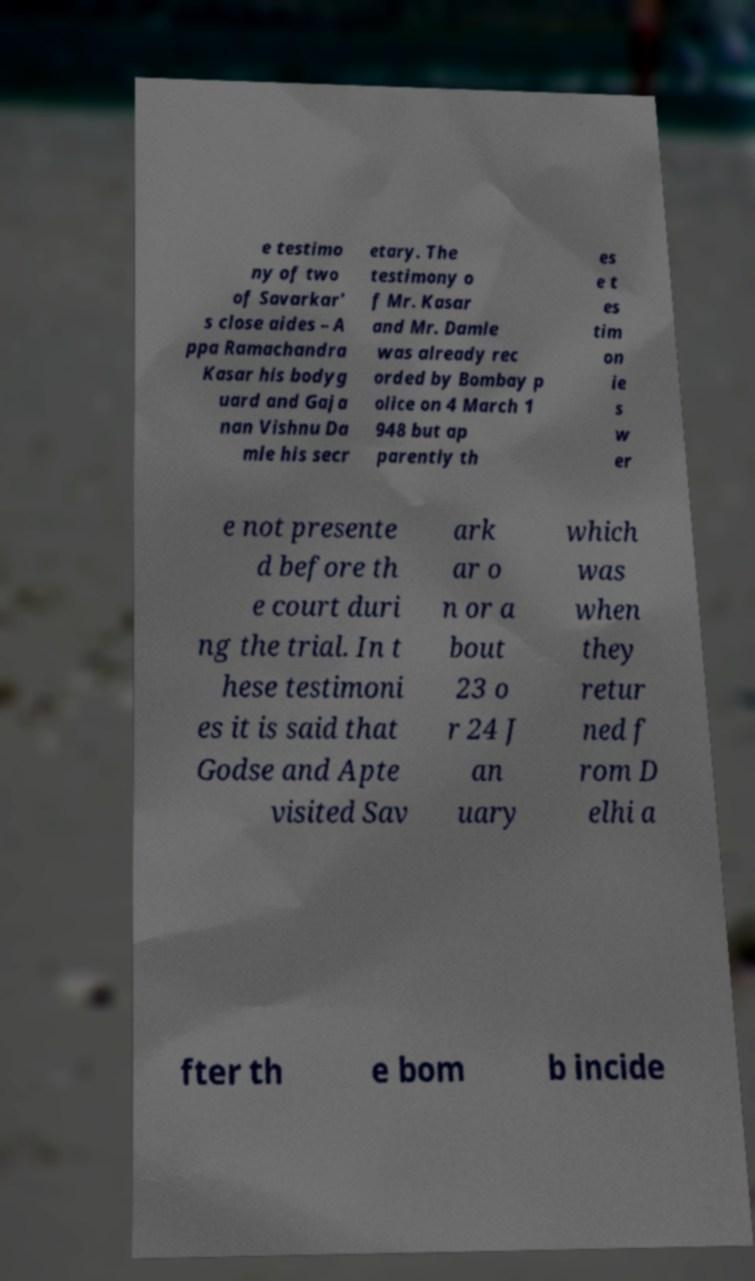Could you assist in decoding the text presented in this image and type it out clearly? e testimo ny of two of Savarkar' s close aides – A ppa Ramachandra Kasar his bodyg uard and Gaja nan Vishnu Da mle his secr etary. The testimony o f Mr. Kasar and Mr. Damle was already rec orded by Bombay p olice on 4 March 1 948 but ap parently th es e t es tim on ie s w er e not presente d before th e court duri ng the trial. In t hese testimoni es it is said that Godse and Apte visited Sav ark ar o n or a bout 23 o r 24 J an uary which was when they retur ned f rom D elhi a fter th e bom b incide 